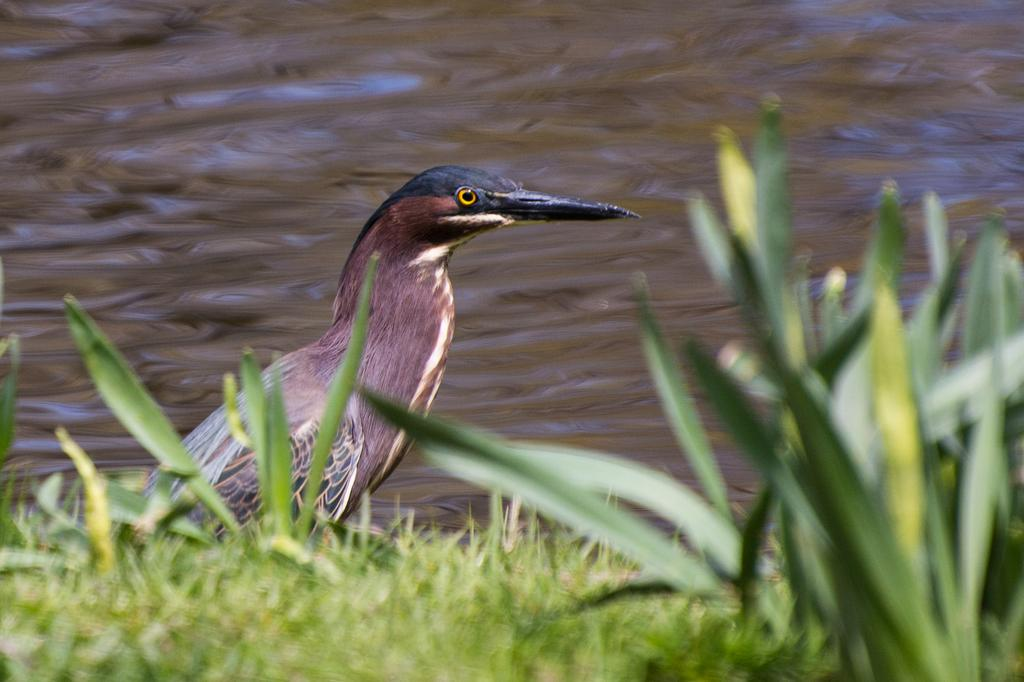What type of animal can be seen in the image? There is a bird in the image. What type of vegetation is present in the image? There is grass and plants in the image. What can be seen in the background of the image? There appears to be water in the background of the image. What type of loaf is being smashed by the bird in the image? There is no loaf present in the image, nor is the bird smashing anything. 